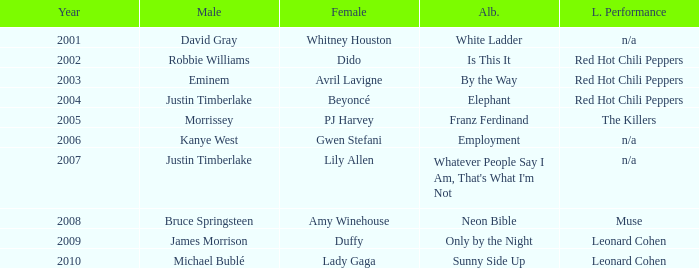Who is the male partner for amy winehouse? Bruce Springsteen. 